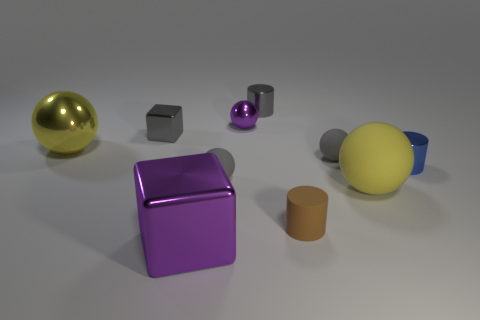Subtract all blue spheres. Subtract all purple cylinders. How many spheres are left? 5 Subtract all cylinders. How many objects are left? 7 Add 8 small gray shiny objects. How many small gray shiny objects are left? 10 Add 2 big red spheres. How many big red spheres exist? 2 Subtract 2 gray spheres. How many objects are left? 8 Subtract all purple metal blocks. Subtract all small matte cylinders. How many objects are left? 8 